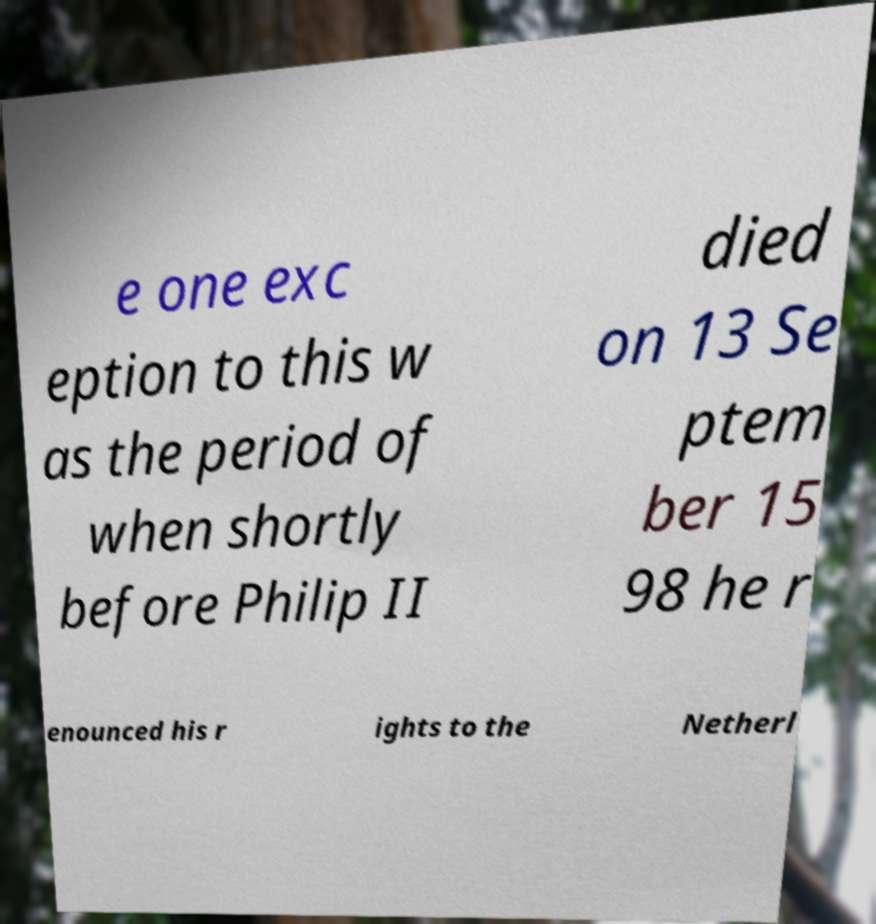For documentation purposes, I need the text within this image transcribed. Could you provide that? e one exc eption to this w as the period of when shortly before Philip II died on 13 Se ptem ber 15 98 he r enounced his r ights to the Netherl 